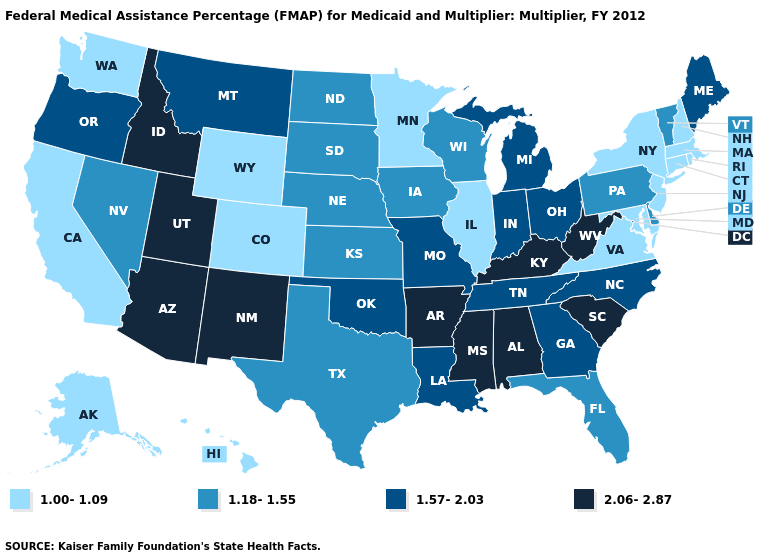Does Ohio have a lower value than Idaho?
Concise answer only. Yes. Name the states that have a value in the range 2.06-2.87?
Concise answer only. Alabama, Arizona, Arkansas, Idaho, Kentucky, Mississippi, New Mexico, South Carolina, Utah, West Virginia. Does Minnesota have the same value as New Hampshire?
Write a very short answer. Yes. Does Kansas have the highest value in the USA?
Answer briefly. No. Does West Virginia have the highest value in the South?
Be succinct. Yes. Name the states that have a value in the range 2.06-2.87?
Concise answer only. Alabama, Arizona, Arkansas, Idaho, Kentucky, Mississippi, New Mexico, South Carolina, Utah, West Virginia. Name the states that have a value in the range 1.18-1.55?
Give a very brief answer. Delaware, Florida, Iowa, Kansas, Nebraska, Nevada, North Dakota, Pennsylvania, South Dakota, Texas, Vermont, Wisconsin. What is the highest value in the MidWest ?
Write a very short answer. 1.57-2.03. Does Nevada have the same value as Montana?
Keep it brief. No. Does the first symbol in the legend represent the smallest category?
Be succinct. Yes. What is the value of Wisconsin?
Quick response, please. 1.18-1.55. What is the lowest value in the USA?
Give a very brief answer. 1.00-1.09. Name the states that have a value in the range 2.06-2.87?
Short answer required. Alabama, Arizona, Arkansas, Idaho, Kentucky, Mississippi, New Mexico, South Carolina, Utah, West Virginia. Name the states that have a value in the range 1.57-2.03?
Be succinct. Georgia, Indiana, Louisiana, Maine, Michigan, Missouri, Montana, North Carolina, Ohio, Oklahoma, Oregon, Tennessee. What is the value of Alabama?
Give a very brief answer. 2.06-2.87. 